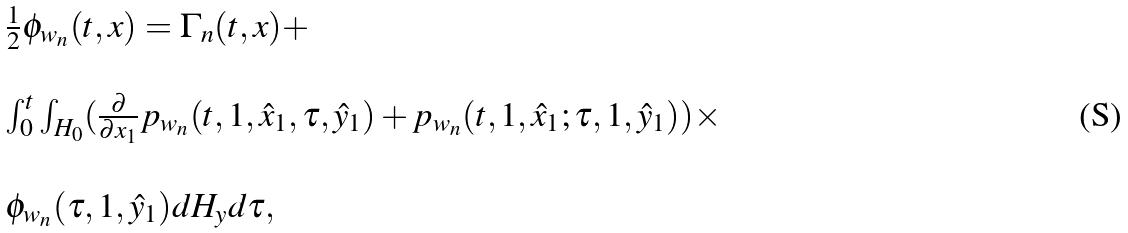Convert formula to latex. <formula><loc_0><loc_0><loc_500><loc_500>\begin{array} { l l } \frac { 1 } { 2 } \phi _ { w _ { n } } ( t , x ) = \Gamma _ { n } ( t , x ) + \\ \\ \int _ { 0 } ^ { t } \int _ { H _ { 0 } } ( \frac { \partial } { \partial x _ { 1 } } p _ { w _ { n } } ( t , 1 , \hat { x } _ { 1 } , \tau , \hat { y } _ { 1 } ) + p _ { w _ { n } } ( t , 1 , \hat { x } _ { 1 } ; \tau , 1 , \hat { y } _ { 1 } ) ) \times \\ \\ \phi _ { w _ { n } } ( \tau , 1 , \hat { y } _ { 1 } ) d H _ { y } d \tau , \end{array}</formula> 